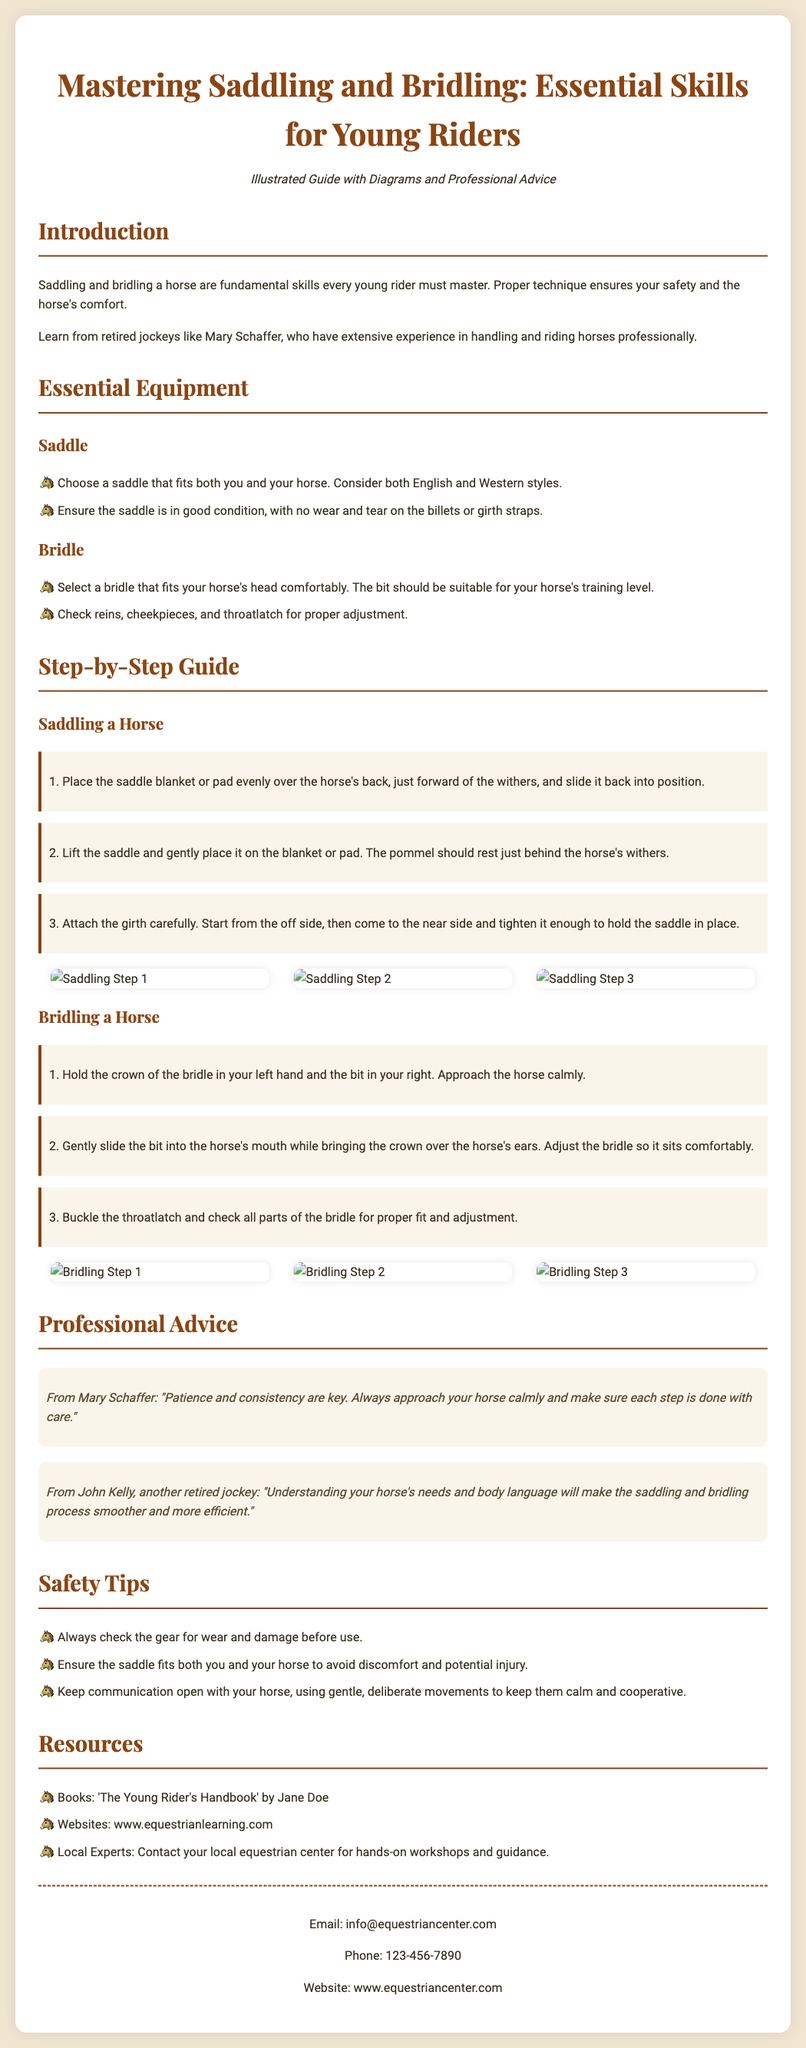What is the title of the guide? The title is stated at the beginning of the document as it introduces the topic covered.
Answer: Mastering Saddling and Bridling: Essential Skills for Young Riders Who is the author of the quote about patience and consistency? The quote is attributed to a specific retired jockey mentioned in the document, providing insight from an expert.
Answer: Mary Schaffer What type of saddle is mentioned in the equipment section? The document specifies types of saddles that are fit for riders and horses in the essential equipment section.
Answer: English and Western styles How many steps are included in the saddling process? The document lists specific numbered steps for the saddling process.
Answer: 3 What should you check for proper adjustment in a bridle? The document lists equipment checks that ensure the bridle fits the horse well, highlighting the importance of comfort.
Answer: Reins, cheekpieces, and throatlatch What is the color of the background mentioned in the style section? The document contains specific details about the visual aspects of the flyer, including colors.
Answer: #f0e6d2 What is the main purpose of this guide? The introduction outlines the primary objective of the guide, emphasizing its educational intent for young riders.
Answer: To master saddling and bridling Which professional advice is shared from another retired jockey? The document includes insights from multiple experts, contributing to the guide's credibility and depth.
Answer: John Kelly 